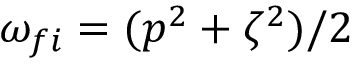<formula> <loc_0><loc_0><loc_500><loc_500>\omega _ { f i } = ( p ^ { 2 } + \zeta ^ { 2 } ) / 2</formula> 